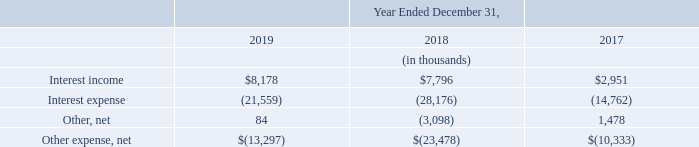Other Income (Expense)
Interest income in 2019 increased by $0.4 million due to an increase in interest income earned on investment securities and money market portfolios.
Interest expense in 2019 decreased by $6.6 million due to the payoff of the 1.50% convertible notes due July 1, 2018 with a principal amount of $253.0 million (the “2018 Notes”) in the third quarter of 2018. Refer to the section titled “Liquidity and Capital Resources” for additional information on the convertible notes.
Other, net primarily included foreign exchange gains and losses related to transactions denominated in foreign currencies, as well as foreign exchange gains and losses related to our intercompany loans and certain cash accounts. Foreign exchange gains and losses for the years ended December 31, 2019, 2018, and 2017, were primarily driven by fluctuations in the euro and US dollar in relation to the British pound.
What does others, net include? Foreign exchange gains and losses related to transactions denominated in foreign currencies, as well as foreign exchange gains and losses related to our intercompany loans and certain cash accounts. What was interest income in 2017?
Answer scale should be: thousand. $2,951. What was others, net in 2019?
Answer scale should be: thousand. 84. What was the percentage change in Interest expense between 2017 and 2018?
Answer scale should be: percent. (-28,176-(-14,762))/(-14,762)
Answer: 90.87. What is the average interest income from 2017-2019?
Answer scale should be: thousand. ($8,178+$7,796+$2,951)/(2019-2017+1)
Answer: 6308.33. What was the percentage change in interest income between 2018 and 2019?
Answer scale should be: percent. ($8,178-$7,796)/$7,796
Answer: 4.9. 